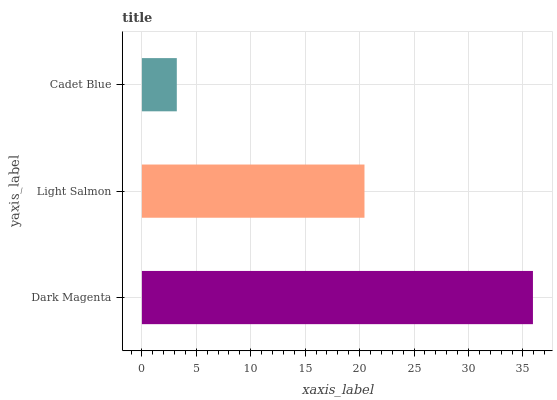Is Cadet Blue the minimum?
Answer yes or no. Yes. Is Dark Magenta the maximum?
Answer yes or no. Yes. Is Light Salmon the minimum?
Answer yes or no. No. Is Light Salmon the maximum?
Answer yes or no. No. Is Dark Magenta greater than Light Salmon?
Answer yes or no. Yes. Is Light Salmon less than Dark Magenta?
Answer yes or no. Yes. Is Light Salmon greater than Dark Magenta?
Answer yes or no. No. Is Dark Magenta less than Light Salmon?
Answer yes or no. No. Is Light Salmon the high median?
Answer yes or no. Yes. Is Light Salmon the low median?
Answer yes or no. Yes. Is Dark Magenta the high median?
Answer yes or no. No. Is Cadet Blue the low median?
Answer yes or no. No. 